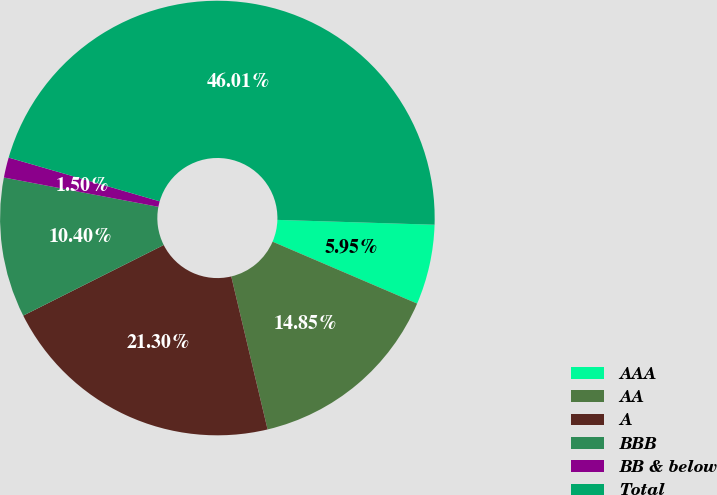<chart> <loc_0><loc_0><loc_500><loc_500><pie_chart><fcel>AAA<fcel>AA<fcel>A<fcel>BBB<fcel>BB & below<fcel>Total<nl><fcel>5.95%<fcel>14.85%<fcel>21.3%<fcel>10.4%<fcel>1.5%<fcel>46.01%<nl></chart> 